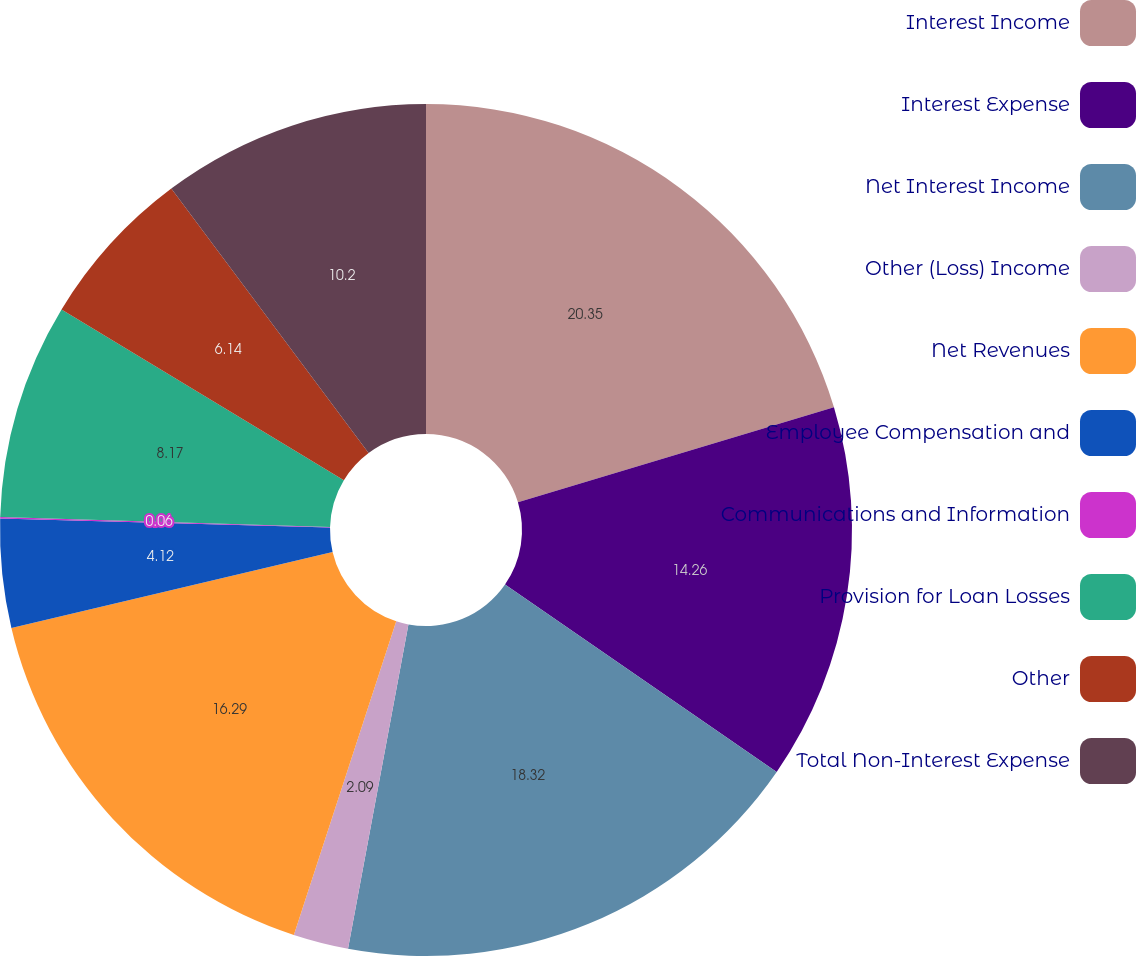Convert chart. <chart><loc_0><loc_0><loc_500><loc_500><pie_chart><fcel>Interest Income<fcel>Interest Expense<fcel>Net Interest Income<fcel>Other (Loss) Income<fcel>Net Revenues<fcel>Employee Compensation and<fcel>Communications and Information<fcel>Provision for Loan Losses<fcel>Other<fcel>Total Non-Interest Expense<nl><fcel>20.35%<fcel>14.26%<fcel>18.32%<fcel>2.09%<fcel>16.29%<fcel>4.12%<fcel>0.06%<fcel>8.17%<fcel>6.14%<fcel>10.2%<nl></chart> 